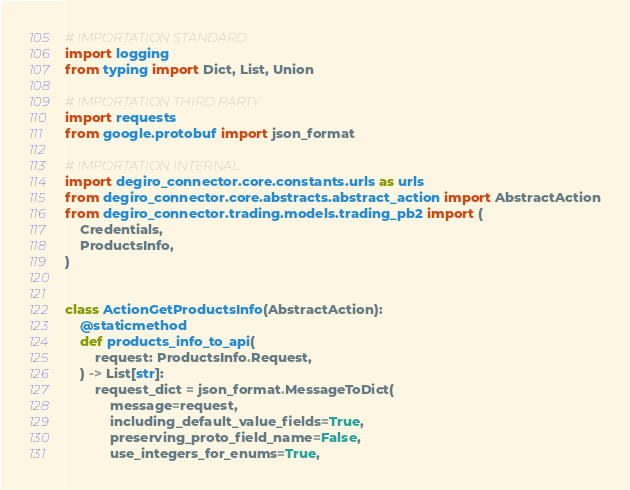<code> <loc_0><loc_0><loc_500><loc_500><_Python_># IMPORTATION STANDARD
import logging
from typing import Dict, List, Union

# IMPORTATION THIRD PARTY
import requests
from google.protobuf import json_format

# IMPORTATION INTERNAL
import degiro_connector.core.constants.urls as urls
from degiro_connector.core.abstracts.abstract_action import AbstractAction
from degiro_connector.trading.models.trading_pb2 import (
    Credentials,
    ProductsInfo,
)


class ActionGetProductsInfo(AbstractAction):
    @staticmethod
    def products_info_to_api(
        request: ProductsInfo.Request,
    ) -> List[str]:
        request_dict = json_format.MessageToDict(
            message=request,
            including_default_value_fields=True,
            preserving_proto_field_name=False,
            use_integers_for_enums=True,</code> 